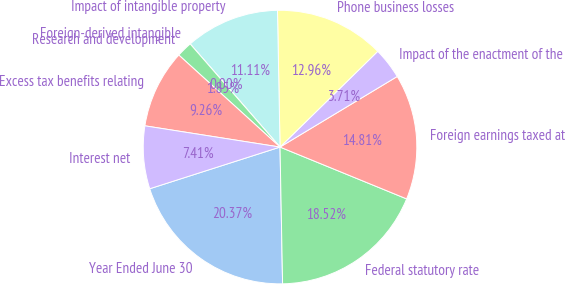Convert chart to OTSL. <chart><loc_0><loc_0><loc_500><loc_500><pie_chart><fcel>Year Ended June 30<fcel>Federal statutory rate<fcel>Foreign earnings taxed at<fcel>Impact of the enactment of the<fcel>Phone business losses<fcel>Impact of intangible property<fcel>Foreign-derived intangible<fcel>Research and development<fcel>Excess tax benefits relating<fcel>Interest net<nl><fcel>20.37%<fcel>18.52%<fcel>14.81%<fcel>3.71%<fcel>12.96%<fcel>11.11%<fcel>0.0%<fcel>1.85%<fcel>9.26%<fcel>7.41%<nl></chart> 